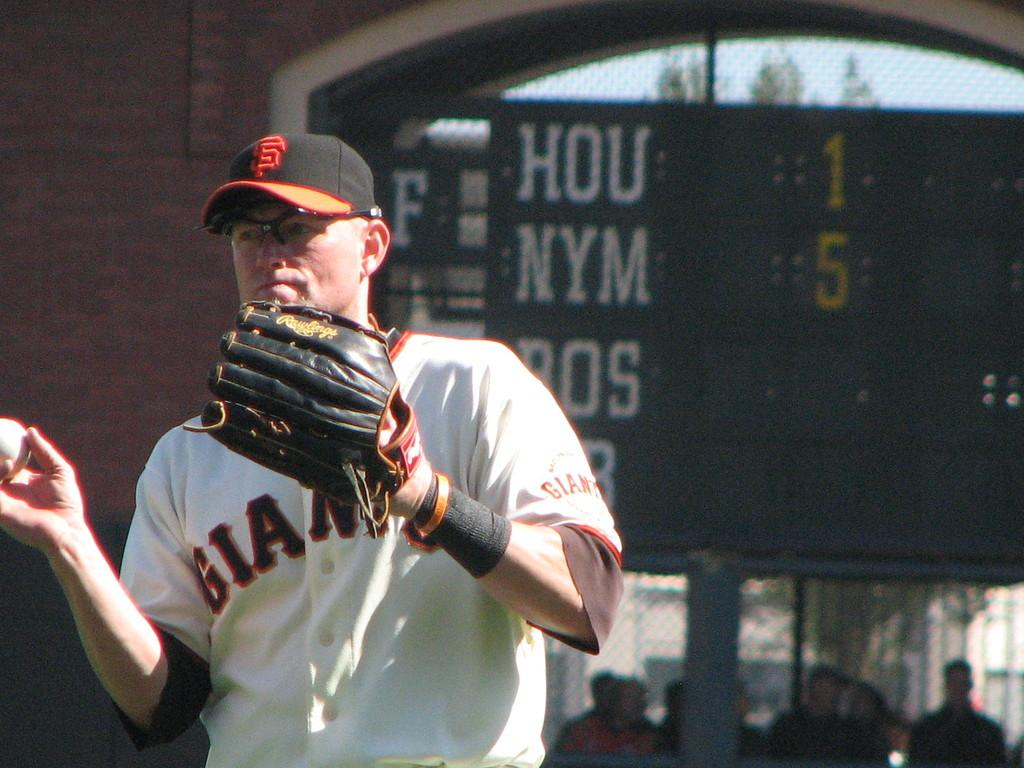<image>
Provide a brief description of the given image. a Giants player that is playing outside on the field 